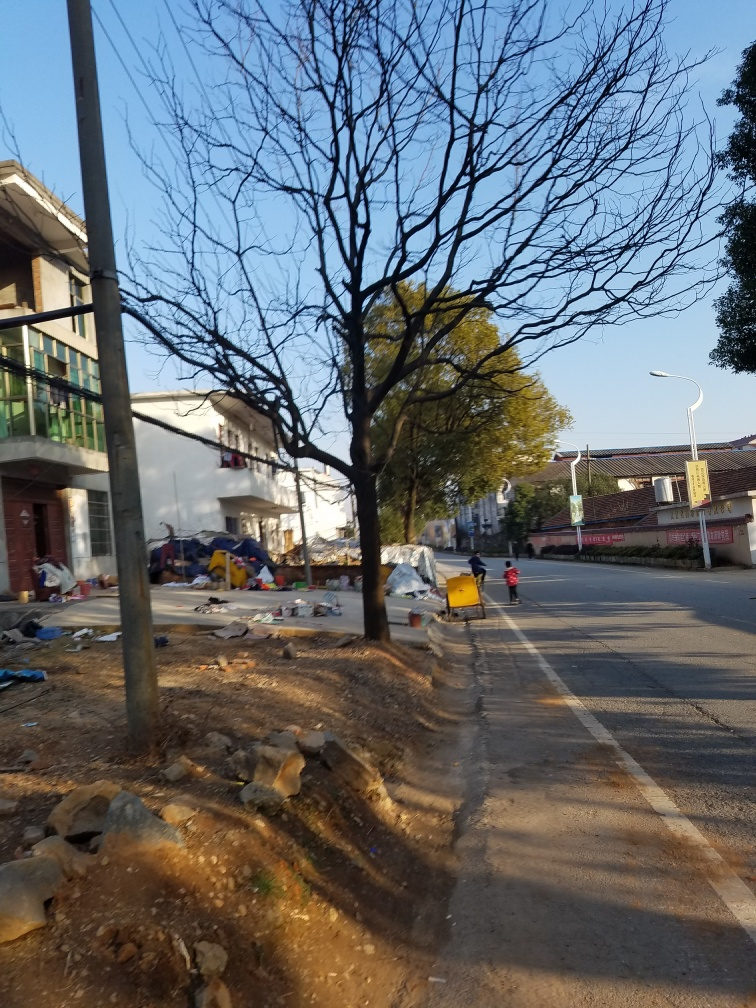Is the overall clarity of the image good? The image is generally clear with distinct elements visible, such as the tree silhouettes against the sky, the street structures, and the child with a scooter on the sidewalk. However, there is slight blurriness in certain areas, possibly due to camera shake or motion, which slightly reduces the overall clarity. 